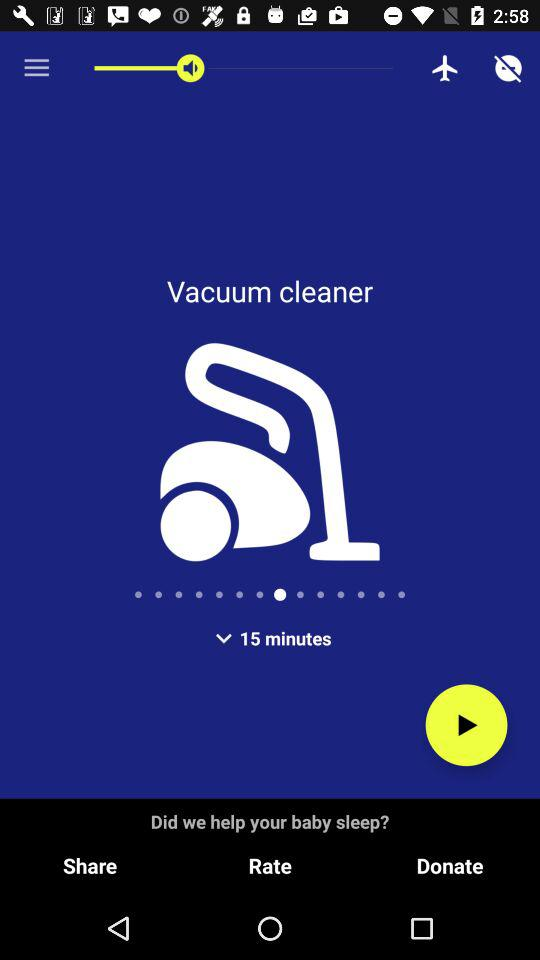How much can be donated?
When the provided information is insufficient, respond with <no answer>. <no answer> 